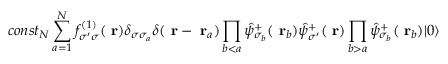Convert formula to latex. <formula><loc_0><loc_0><loc_500><loc_500>c o n s t _ { N } \sum _ { a = 1 } ^ { N } f _ { \sigma ^ { \prime } \sigma } ^ { ( 1 ) } ( r ) \delta _ { \sigma \sigma _ { a } } \delta ( r - r _ { a } ) \prod _ { b < a } \hat { \psi } _ { \sigma _ { b } } ^ { + } ( r _ { b } ) \hat { \psi } _ { \sigma ^ { \prime } } ^ { + } ( r ) \prod _ { b > a } \hat { \psi } _ { \sigma _ { b } } ^ { + } ( r _ { b } ) | 0 \rangle</formula> 